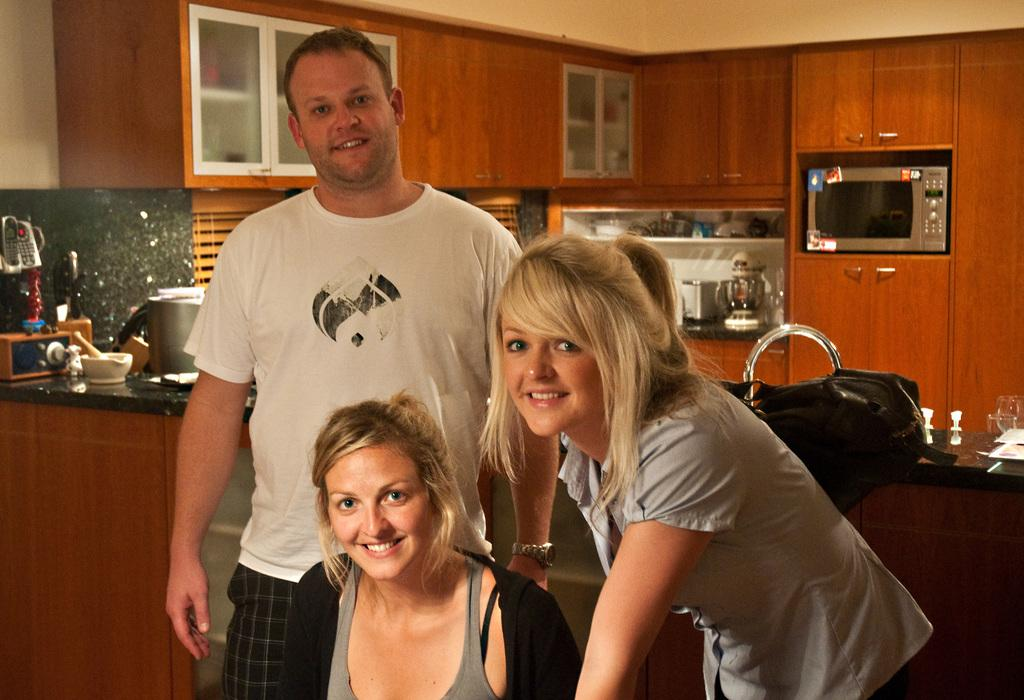How many persons are in the image? There are three persons in the image. What are the persons doing in the image? The persons are posing for a camera and smiling. What can be seen in the background of the image? There are cupboards, an oven, a jar, bowls, glasses, and a bag in the background of the image. Can you tell me what type of toad is sitting on the bag in the image? There is no toad present in the image; it only features three persons posing for a camera and various objects in the background. 